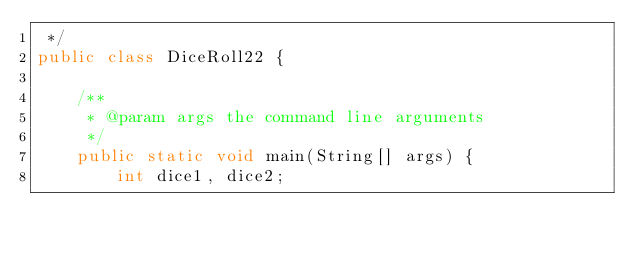<code> <loc_0><loc_0><loc_500><loc_500><_Java_> */
public class DiceRoll22 {

    /**
     * @param args the command line arguments
     */
    public static void main(String[] args) {
        int dice1, dice2;</code> 